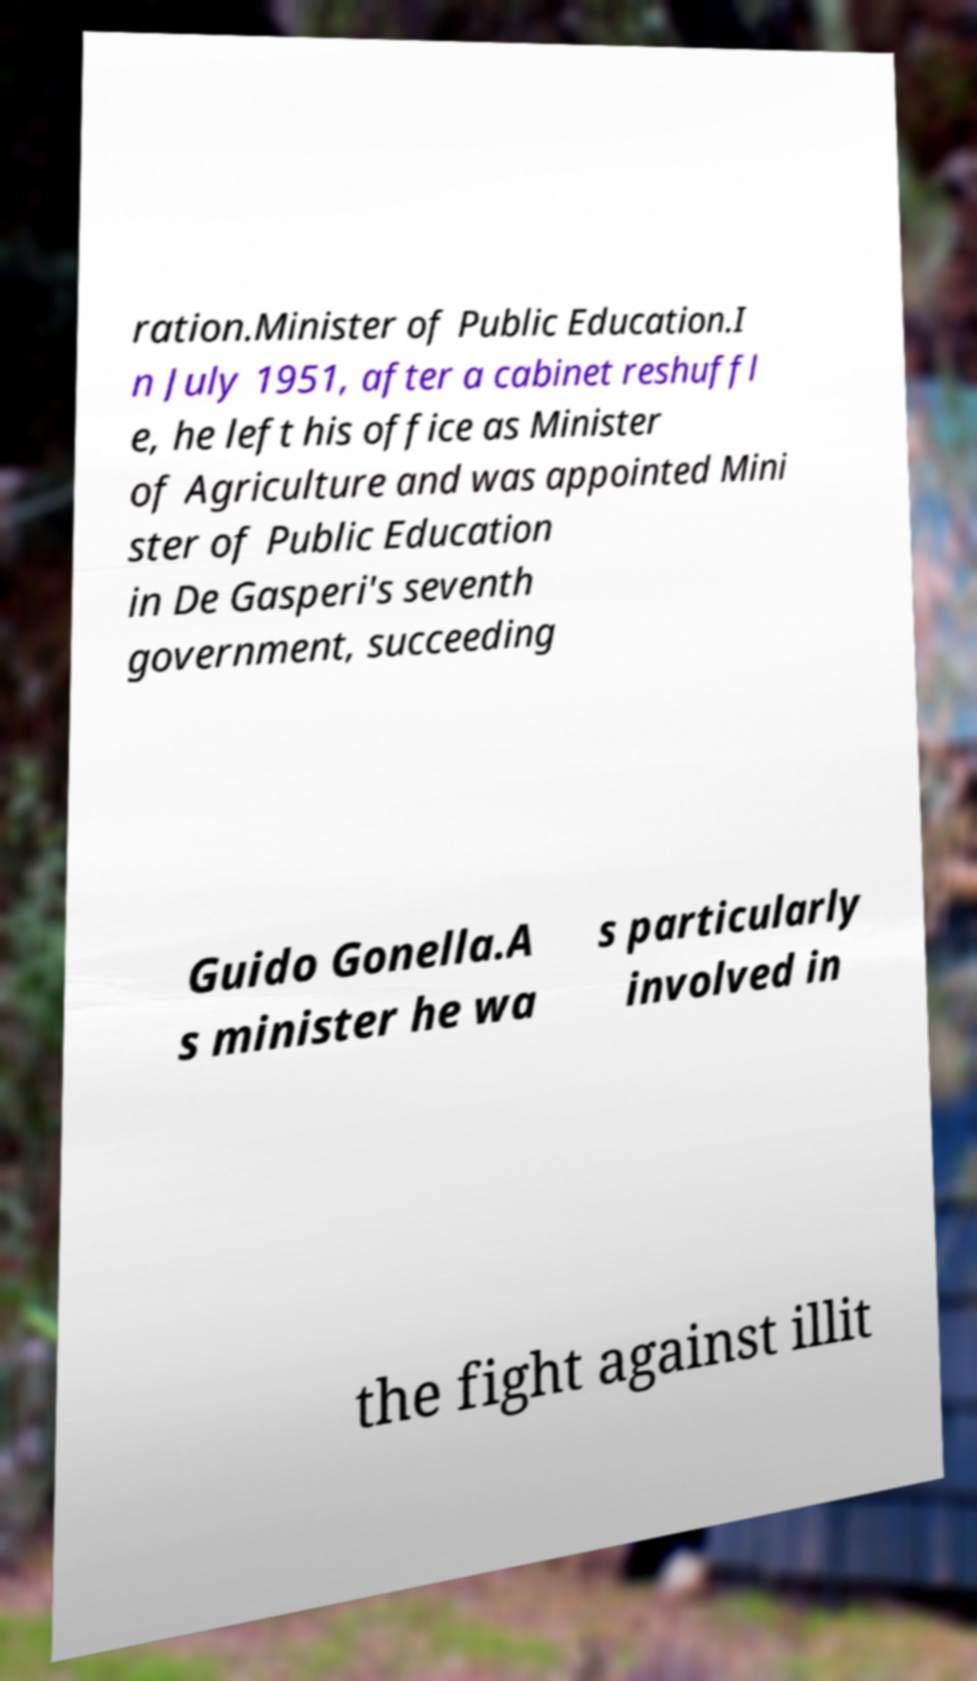Please identify and transcribe the text found in this image. ration.Minister of Public Education.I n July 1951, after a cabinet reshuffl e, he left his office as Minister of Agriculture and was appointed Mini ster of Public Education in De Gasperi's seventh government, succeeding Guido Gonella.A s minister he wa s particularly involved in the fight against illit 